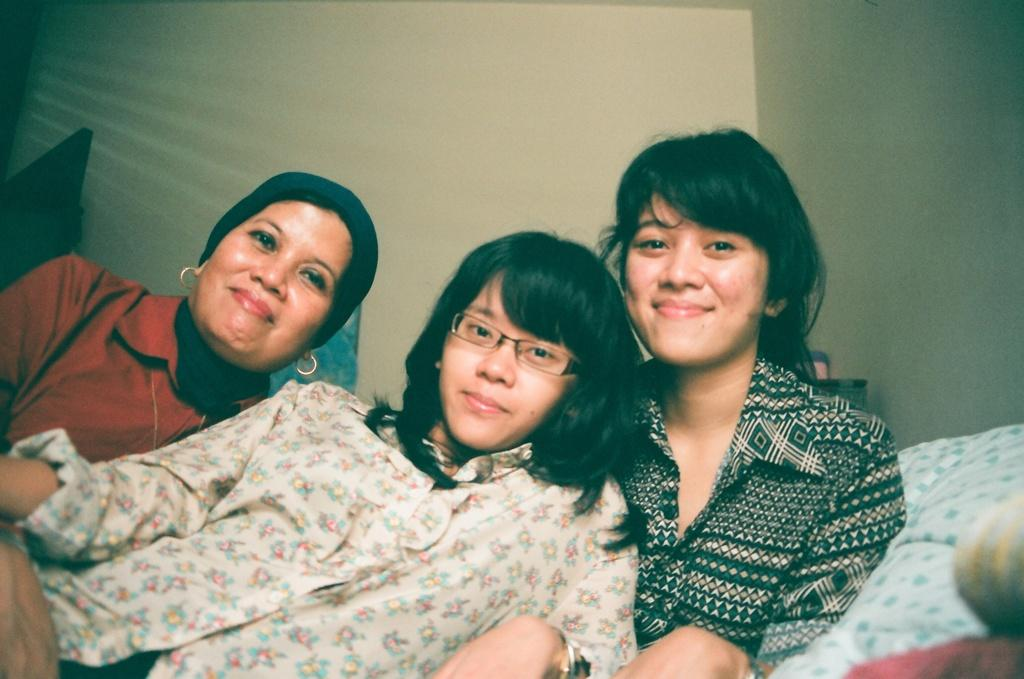How many women are in the image? There are three women in the image. What are the women doing in the image? The women are sitting together and leaning into each other. What is the facial expression of the women in the image? The women are smiling in the image. What can be seen in the background of the image? There is a wall visible in the background of the image. What type of hose is being used by the women in the image? There is no hose present in the image; the women are sitting together and smiling. How does the concept of love manifest in the image? The concept of love is not explicitly depicted in the image, but the women's smiles and close proximity might suggest a sense of camaraderie or affection. 